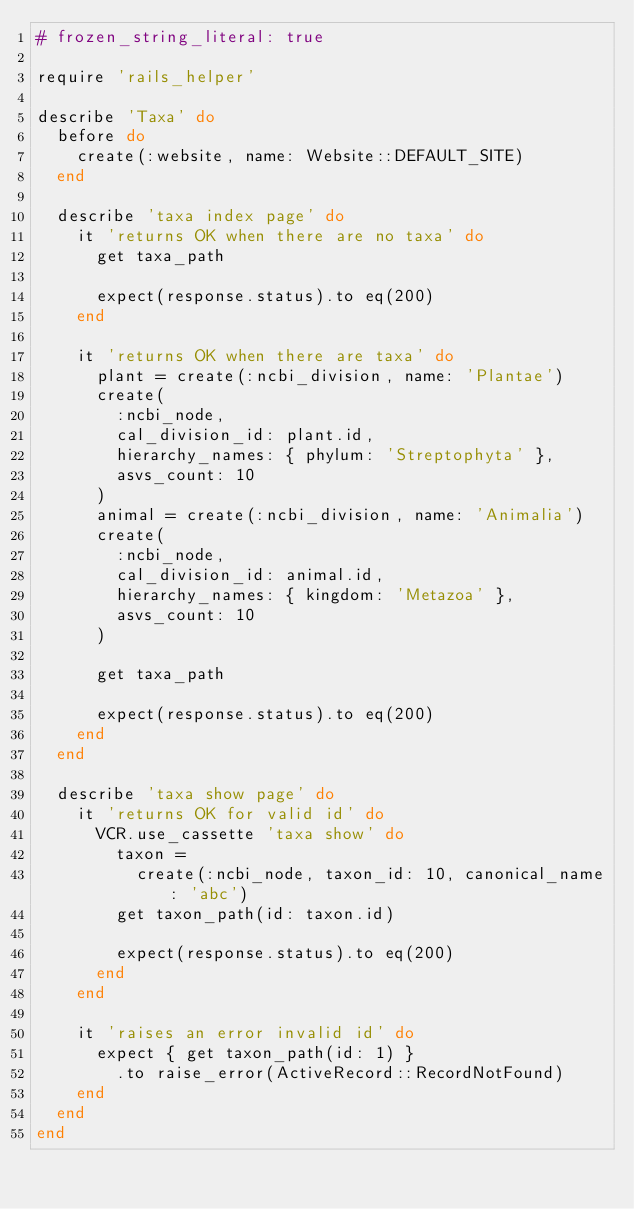Convert code to text. <code><loc_0><loc_0><loc_500><loc_500><_Ruby_># frozen_string_literal: true

require 'rails_helper'

describe 'Taxa' do
  before do
    create(:website, name: Website::DEFAULT_SITE)
  end

  describe 'taxa index page' do
    it 'returns OK when there are no taxa' do
      get taxa_path

      expect(response.status).to eq(200)
    end

    it 'returns OK when there are taxa' do
      plant = create(:ncbi_division, name: 'Plantae')
      create(
        :ncbi_node,
        cal_division_id: plant.id,
        hierarchy_names: { phylum: 'Streptophyta' },
        asvs_count: 10
      )
      animal = create(:ncbi_division, name: 'Animalia')
      create(
        :ncbi_node,
        cal_division_id: animal.id,
        hierarchy_names: { kingdom: 'Metazoa' },
        asvs_count: 10
      )

      get taxa_path

      expect(response.status).to eq(200)
    end
  end

  describe 'taxa show page' do
    it 'returns OK for valid id' do
      VCR.use_cassette 'taxa show' do
        taxon =
          create(:ncbi_node, taxon_id: 10, canonical_name: 'abc')
        get taxon_path(id: taxon.id)

        expect(response.status).to eq(200)
      end
    end

    it 'raises an error invalid id' do
      expect { get taxon_path(id: 1) }
        .to raise_error(ActiveRecord::RecordNotFound)
    end
  end
end
</code> 